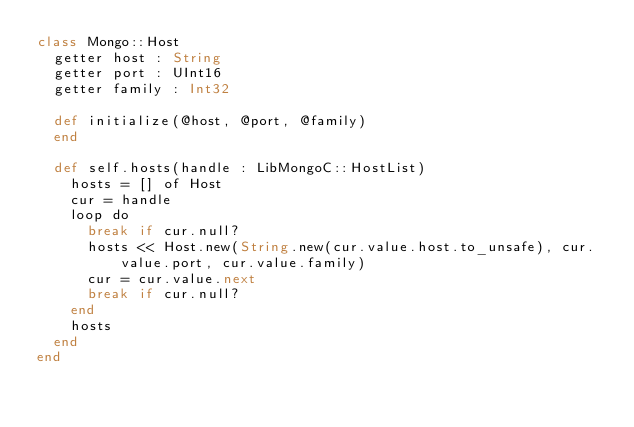Convert code to text. <code><loc_0><loc_0><loc_500><loc_500><_Crystal_>class Mongo::Host
  getter host : String
  getter port : UInt16
  getter family : Int32

  def initialize(@host, @port, @family)
  end

  def self.hosts(handle : LibMongoC::HostList)
    hosts = [] of Host
    cur = handle
    loop do
      break if cur.null?
      hosts << Host.new(String.new(cur.value.host.to_unsafe), cur.value.port, cur.value.family)
      cur = cur.value.next
      break if cur.null?
    end
    hosts
  end
end
</code> 